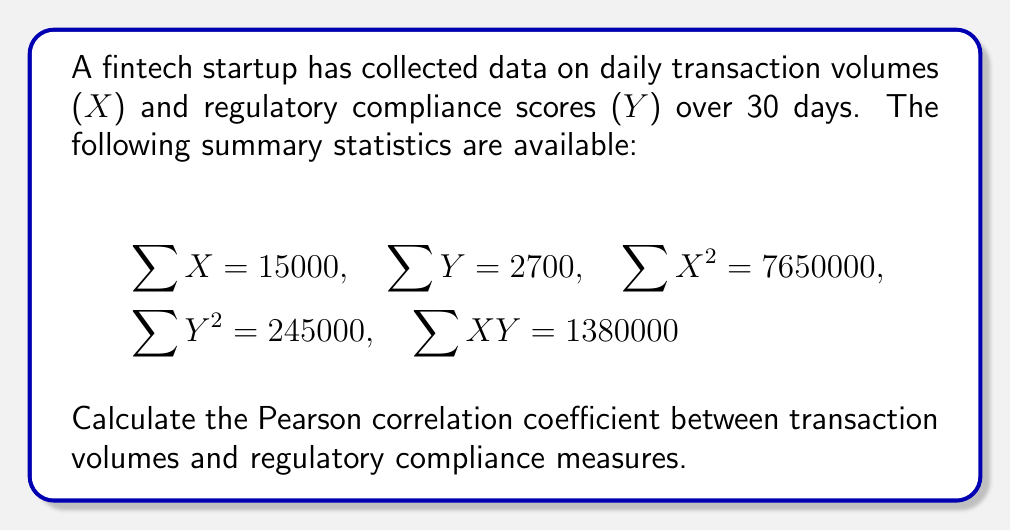Provide a solution to this math problem. To calculate the Pearson correlation coefficient, we'll use the formula:

$$r = \frac{n\sum XY - \sum X \sum Y}{\sqrt{[n\sum X^2 - (\sum X)^2][n\sum Y^2 - (\sum Y)^2]}}$$

Where $n$ is the number of data points (30 in this case).

Step 1: Calculate $n\sum XY$
$30 \times 1380000 = 41400000$

Step 2: Calculate $\sum X \sum Y$
$15000 \times 2700 = 40500000$

Step 3: Calculate the numerator
$41400000 - 40500000 = 900000$

Step 4: Calculate $n\sum X^2$
$30 \times 7650000 = 229500000$

Step 5: Calculate $(\sum X)^2$
$15000^2 = 225000000$

Step 6: Calculate $n\sum Y^2$
$30 \times 245000 = 7350000$

Step 7: Calculate $(\sum Y)^2$
$2700^2 = 7290000$

Step 8: Calculate the denominator
$\sqrt{[229500000 - 225000000][7350000 - 7290000]}$
$= \sqrt{4500000 \times 60000}$
$= \sqrt{270000000000}$
$= 519615.24$

Step 9: Calculate the correlation coefficient
$r = \frac{900000}{519615.24} \approx 1.73$
Answer: $r \approx 1.73$ 